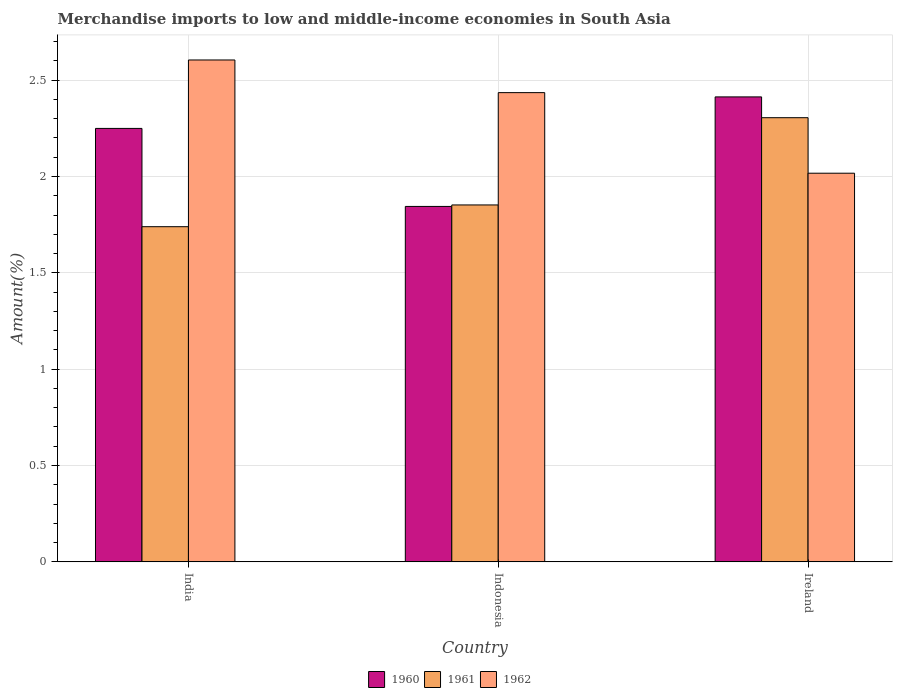Are the number of bars on each tick of the X-axis equal?
Ensure brevity in your answer.  Yes. How many bars are there on the 1st tick from the left?
Your response must be concise. 3. How many bars are there on the 2nd tick from the right?
Make the answer very short. 3. What is the label of the 3rd group of bars from the left?
Your response must be concise. Ireland. In how many cases, is the number of bars for a given country not equal to the number of legend labels?
Give a very brief answer. 0. What is the percentage of amount earned from merchandise imports in 1961 in Indonesia?
Ensure brevity in your answer.  1.85. Across all countries, what is the maximum percentage of amount earned from merchandise imports in 1960?
Your response must be concise. 2.41. Across all countries, what is the minimum percentage of amount earned from merchandise imports in 1962?
Provide a short and direct response. 2.02. In which country was the percentage of amount earned from merchandise imports in 1960 maximum?
Your response must be concise. Ireland. In which country was the percentage of amount earned from merchandise imports in 1960 minimum?
Offer a very short reply. Indonesia. What is the total percentage of amount earned from merchandise imports in 1962 in the graph?
Your answer should be compact. 7.06. What is the difference between the percentage of amount earned from merchandise imports in 1962 in India and that in Indonesia?
Ensure brevity in your answer.  0.17. What is the difference between the percentage of amount earned from merchandise imports in 1962 in India and the percentage of amount earned from merchandise imports in 1961 in Ireland?
Offer a very short reply. 0.3. What is the average percentage of amount earned from merchandise imports in 1961 per country?
Offer a very short reply. 1.97. What is the difference between the percentage of amount earned from merchandise imports of/in 1960 and percentage of amount earned from merchandise imports of/in 1962 in Ireland?
Keep it short and to the point. 0.4. What is the ratio of the percentage of amount earned from merchandise imports in 1961 in Indonesia to that in Ireland?
Ensure brevity in your answer.  0.8. Is the percentage of amount earned from merchandise imports in 1962 in India less than that in Indonesia?
Your answer should be compact. No. Is the difference between the percentage of amount earned from merchandise imports in 1960 in India and Ireland greater than the difference between the percentage of amount earned from merchandise imports in 1962 in India and Ireland?
Ensure brevity in your answer.  No. What is the difference between the highest and the second highest percentage of amount earned from merchandise imports in 1961?
Your answer should be very brief. -0.45. What is the difference between the highest and the lowest percentage of amount earned from merchandise imports in 1960?
Ensure brevity in your answer.  0.57. What does the 1st bar from the right in India represents?
Offer a very short reply. 1962. Is it the case that in every country, the sum of the percentage of amount earned from merchandise imports in 1961 and percentage of amount earned from merchandise imports in 1960 is greater than the percentage of amount earned from merchandise imports in 1962?
Ensure brevity in your answer.  Yes. How many bars are there?
Provide a short and direct response. 9. How many countries are there in the graph?
Provide a short and direct response. 3. What is the difference between two consecutive major ticks on the Y-axis?
Your answer should be compact. 0.5. How many legend labels are there?
Ensure brevity in your answer.  3. What is the title of the graph?
Your answer should be very brief. Merchandise imports to low and middle-income economies in South Asia. What is the label or title of the X-axis?
Keep it short and to the point. Country. What is the label or title of the Y-axis?
Give a very brief answer. Amount(%). What is the Amount(%) of 1960 in India?
Provide a short and direct response. 2.25. What is the Amount(%) of 1961 in India?
Give a very brief answer. 1.74. What is the Amount(%) of 1962 in India?
Keep it short and to the point. 2.6. What is the Amount(%) of 1960 in Indonesia?
Provide a short and direct response. 1.84. What is the Amount(%) in 1961 in Indonesia?
Your response must be concise. 1.85. What is the Amount(%) in 1962 in Indonesia?
Your response must be concise. 2.44. What is the Amount(%) of 1960 in Ireland?
Provide a short and direct response. 2.41. What is the Amount(%) in 1961 in Ireland?
Keep it short and to the point. 2.31. What is the Amount(%) in 1962 in Ireland?
Give a very brief answer. 2.02. Across all countries, what is the maximum Amount(%) of 1960?
Keep it short and to the point. 2.41. Across all countries, what is the maximum Amount(%) in 1961?
Offer a very short reply. 2.31. Across all countries, what is the maximum Amount(%) of 1962?
Keep it short and to the point. 2.6. Across all countries, what is the minimum Amount(%) in 1960?
Provide a succinct answer. 1.84. Across all countries, what is the minimum Amount(%) of 1961?
Provide a short and direct response. 1.74. Across all countries, what is the minimum Amount(%) of 1962?
Provide a succinct answer. 2.02. What is the total Amount(%) of 1960 in the graph?
Your answer should be compact. 6.51. What is the total Amount(%) of 1961 in the graph?
Make the answer very short. 5.9. What is the total Amount(%) in 1962 in the graph?
Give a very brief answer. 7.06. What is the difference between the Amount(%) in 1960 in India and that in Indonesia?
Provide a succinct answer. 0.4. What is the difference between the Amount(%) in 1961 in India and that in Indonesia?
Give a very brief answer. -0.11. What is the difference between the Amount(%) in 1962 in India and that in Indonesia?
Keep it short and to the point. 0.17. What is the difference between the Amount(%) of 1960 in India and that in Ireland?
Ensure brevity in your answer.  -0.16. What is the difference between the Amount(%) in 1961 in India and that in Ireland?
Offer a very short reply. -0.57. What is the difference between the Amount(%) of 1962 in India and that in Ireland?
Give a very brief answer. 0.59. What is the difference between the Amount(%) of 1960 in Indonesia and that in Ireland?
Offer a very short reply. -0.57. What is the difference between the Amount(%) in 1961 in Indonesia and that in Ireland?
Give a very brief answer. -0.45. What is the difference between the Amount(%) of 1962 in Indonesia and that in Ireland?
Ensure brevity in your answer.  0.42. What is the difference between the Amount(%) of 1960 in India and the Amount(%) of 1961 in Indonesia?
Offer a very short reply. 0.4. What is the difference between the Amount(%) of 1960 in India and the Amount(%) of 1962 in Indonesia?
Make the answer very short. -0.19. What is the difference between the Amount(%) in 1961 in India and the Amount(%) in 1962 in Indonesia?
Your answer should be very brief. -0.7. What is the difference between the Amount(%) of 1960 in India and the Amount(%) of 1961 in Ireland?
Provide a succinct answer. -0.06. What is the difference between the Amount(%) of 1960 in India and the Amount(%) of 1962 in Ireland?
Offer a terse response. 0.23. What is the difference between the Amount(%) in 1961 in India and the Amount(%) in 1962 in Ireland?
Offer a terse response. -0.28. What is the difference between the Amount(%) in 1960 in Indonesia and the Amount(%) in 1961 in Ireland?
Offer a terse response. -0.46. What is the difference between the Amount(%) of 1960 in Indonesia and the Amount(%) of 1962 in Ireland?
Offer a very short reply. -0.17. What is the difference between the Amount(%) of 1961 in Indonesia and the Amount(%) of 1962 in Ireland?
Provide a short and direct response. -0.16. What is the average Amount(%) of 1960 per country?
Make the answer very short. 2.17. What is the average Amount(%) in 1961 per country?
Provide a succinct answer. 1.97. What is the average Amount(%) in 1962 per country?
Your answer should be very brief. 2.35. What is the difference between the Amount(%) in 1960 and Amount(%) in 1961 in India?
Your response must be concise. 0.51. What is the difference between the Amount(%) in 1960 and Amount(%) in 1962 in India?
Offer a terse response. -0.36. What is the difference between the Amount(%) in 1961 and Amount(%) in 1962 in India?
Your response must be concise. -0.87. What is the difference between the Amount(%) in 1960 and Amount(%) in 1961 in Indonesia?
Provide a short and direct response. -0.01. What is the difference between the Amount(%) in 1960 and Amount(%) in 1962 in Indonesia?
Make the answer very short. -0.59. What is the difference between the Amount(%) of 1961 and Amount(%) of 1962 in Indonesia?
Keep it short and to the point. -0.58. What is the difference between the Amount(%) in 1960 and Amount(%) in 1961 in Ireland?
Make the answer very short. 0.11. What is the difference between the Amount(%) in 1960 and Amount(%) in 1962 in Ireland?
Your answer should be compact. 0.4. What is the difference between the Amount(%) in 1961 and Amount(%) in 1962 in Ireland?
Your answer should be very brief. 0.29. What is the ratio of the Amount(%) in 1960 in India to that in Indonesia?
Give a very brief answer. 1.22. What is the ratio of the Amount(%) in 1961 in India to that in Indonesia?
Ensure brevity in your answer.  0.94. What is the ratio of the Amount(%) in 1962 in India to that in Indonesia?
Your answer should be compact. 1.07. What is the ratio of the Amount(%) of 1960 in India to that in Ireland?
Offer a very short reply. 0.93. What is the ratio of the Amount(%) of 1961 in India to that in Ireland?
Ensure brevity in your answer.  0.75. What is the ratio of the Amount(%) in 1962 in India to that in Ireland?
Give a very brief answer. 1.29. What is the ratio of the Amount(%) of 1960 in Indonesia to that in Ireland?
Keep it short and to the point. 0.76. What is the ratio of the Amount(%) of 1961 in Indonesia to that in Ireland?
Your answer should be very brief. 0.8. What is the ratio of the Amount(%) in 1962 in Indonesia to that in Ireland?
Your answer should be very brief. 1.21. What is the difference between the highest and the second highest Amount(%) in 1960?
Ensure brevity in your answer.  0.16. What is the difference between the highest and the second highest Amount(%) in 1961?
Your answer should be compact. 0.45. What is the difference between the highest and the second highest Amount(%) of 1962?
Offer a very short reply. 0.17. What is the difference between the highest and the lowest Amount(%) of 1960?
Your answer should be very brief. 0.57. What is the difference between the highest and the lowest Amount(%) in 1961?
Your answer should be very brief. 0.57. What is the difference between the highest and the lowest Amount(%) in 1962?
Your response must be concise. 0.59. 